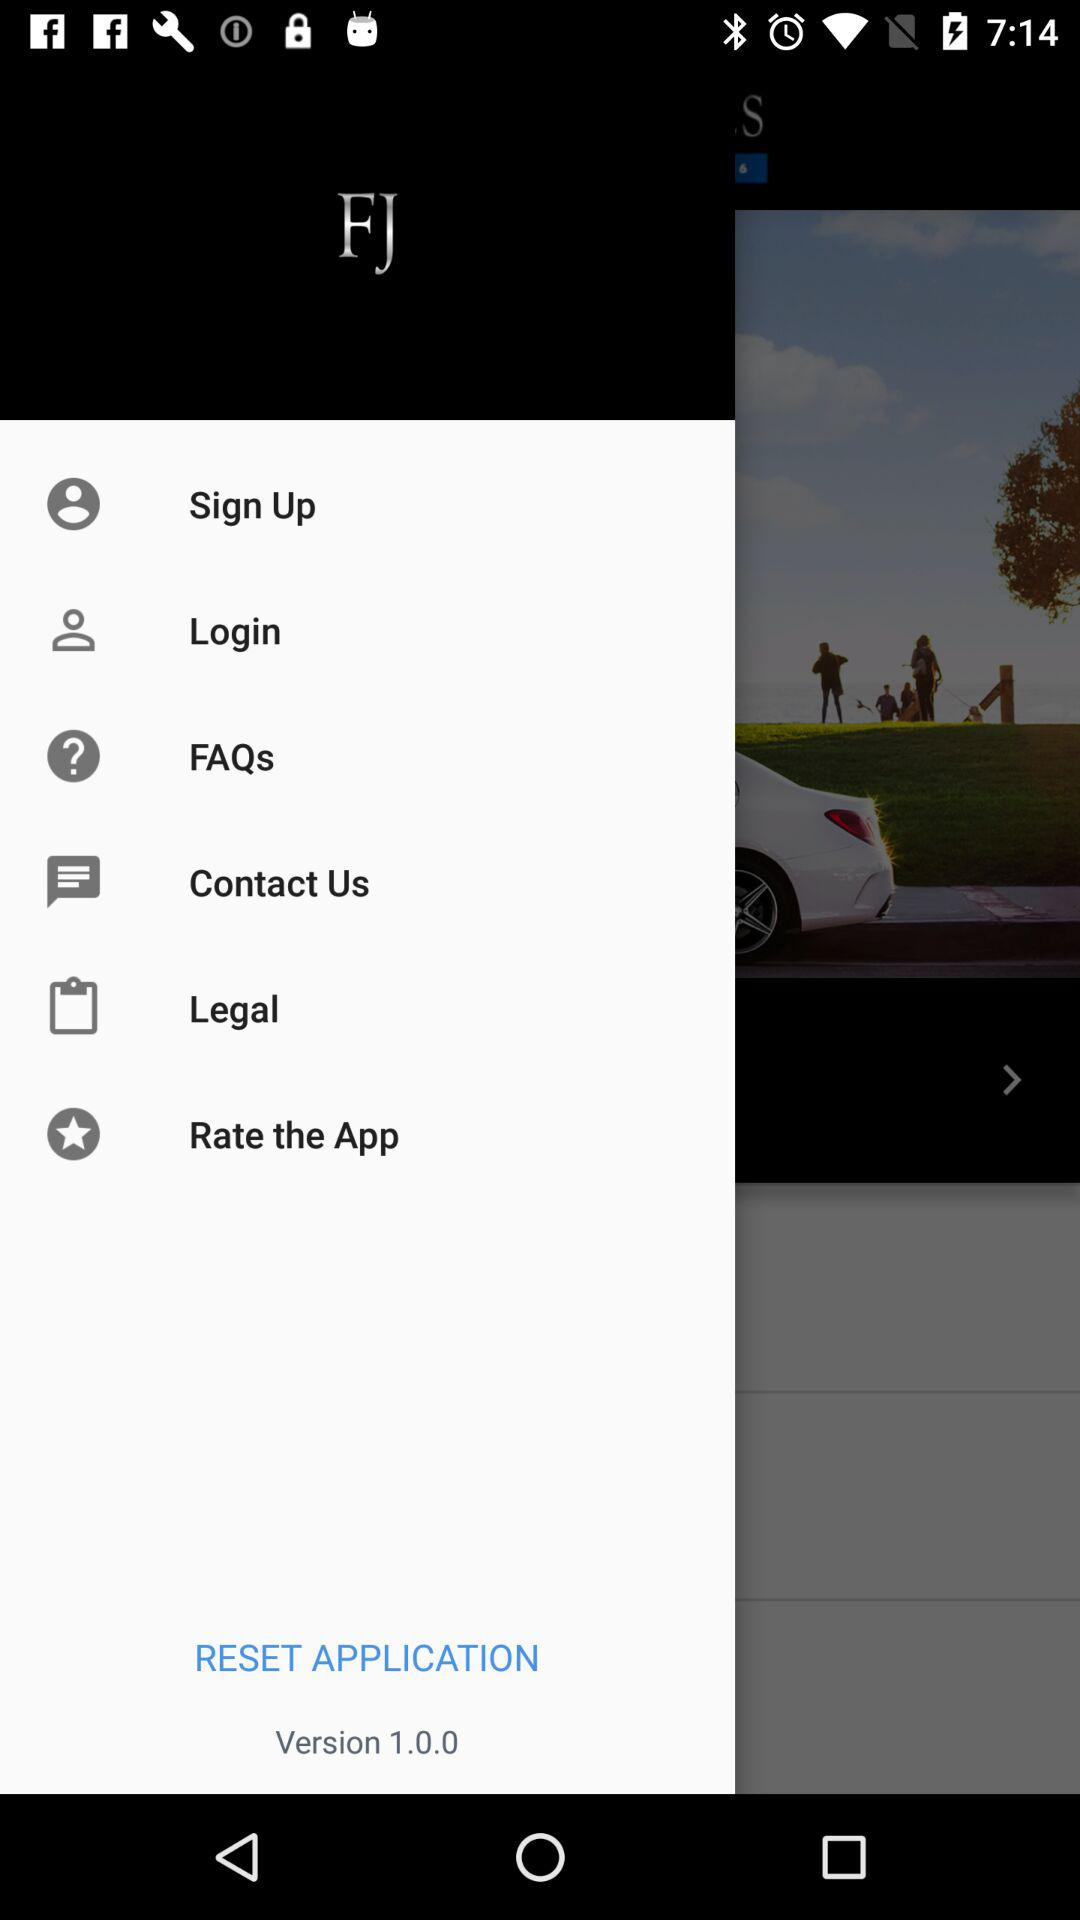When was version 1.0.0 released?
When the provided information is insufficient, respond with <no answer>. <no answer> 